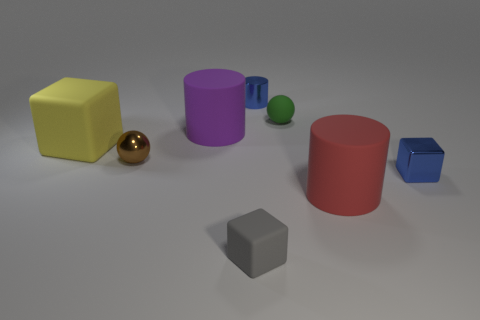Subtract all big yellow blocks. How many blocks are left? 2 Add 1 shiny blocks. How many objects exist? 9 Subtract all cylinders. How many objects are left? 5 Subtract all green spheres. How many spheres are left? 1 Subtract 2 cubes. How many cubes are left? 1 Add 4 large rubber cubes. How many large rubber cubes exist? 5 Subtract 1 gray blocks. How many objects are left? 7 Subtract all yellow spheres. Subtract all brown cylinders. How many spheres are left? 2 Subtract all large purple cylinders. Subtract all big rubber things. How many objects are left? 4 Add 4 tiny blue metal objects. How many tiny blue metal objects are left? 6 